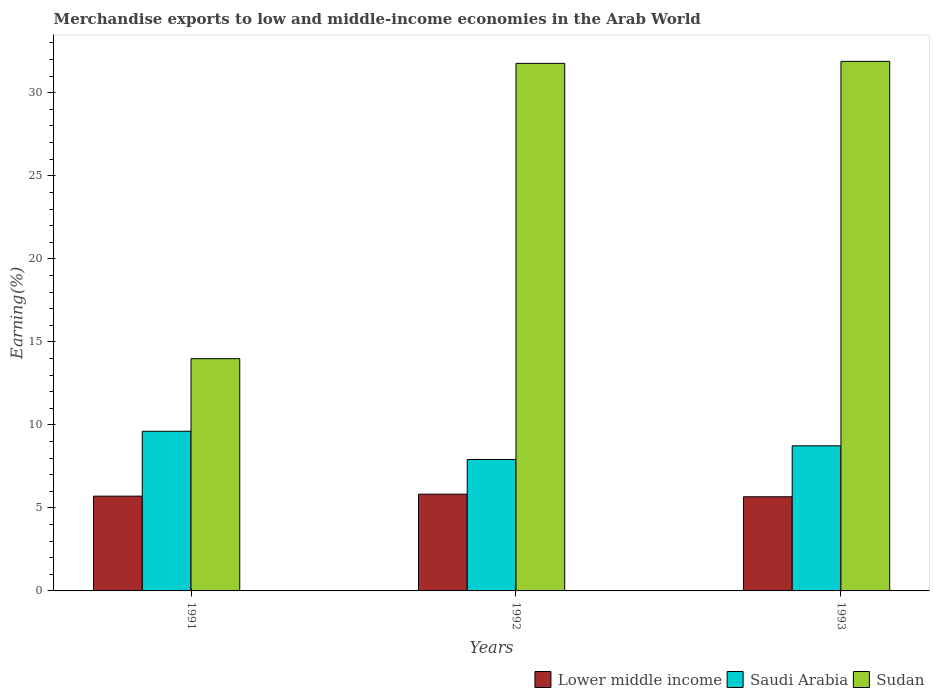How many groups of bars are there?
Give a very brief answer. 3. Are the number of bars on each tick of the X-axis equal?
Offer a terse response. Yes. How many bars are there on the 3rd tick from the left?
Your answer should be compact. 3. What is the label of the 1st group of bars from the left?
Make the answer very short. 1991. What is the percentage of amount earned from merchandise exports in Lower middle income in 1992?
Offer a terse response. 5.83. Across all years, what is the maximum percentage of amount earned from merchandise exports in Saudi Arabia?
Make the answer very short. 9.62. Across all years, what is the minimum percentage of amount earned from merchandise exports in Sudan?
Your answer should be very brief. 13.99. In which year was the percentage of amount earned from merchandise exports in Lower middle income minimum?
Make the answer very short. 1993. What is the total percentage of amount earned from merchandise exports in Saudi Arabia in the graph?
Provide a succinct answer. 26.27. What is the difference between the percentage of amount earned from merchandise exports in Lower middle income in 1991 and that in 1992?
Ensure brevity in your answer.  -0.12. What is the difference between the percentage of amount earned from merchandise exports in Saudi Arabia in 1992 and the percentage of amount earned from merchandise exports in Lower middle income in 1993?
Provide a short and direct response. 2.24. What is the average percentage of amount earned from merchandise exports in Sudan per year?
Offer a terse response. 25.88. In the year 1993, what is the difference between the percentage of amount earned from merchandise exports in Saudi Arabia and percentage of amount earned from merchandise exports in Sudan?
Ensure brevity in your answer.  -23.15. In how many years, is the percentage of amount earned from merchandise exports in Lower middle income greater than 17 %?
Give a very brief answer. 0. What is the ratio of the percentage of amount earned from merchandise exports in Saudi Arabia in 1991 to that in 1992?
Your answer should be compact. 1.22. Is the percentage of amount earned from merchandise exports in Sudan in 1991 less than that in 1992?
Provide a short and direct response. Yes. What is the difference between the highest and the second highest percentage of amount earned from merchandise exports in Sudan?
Offer a terse response. 0.12. What is the difference between the highest and the lowest percentage of amount earned from merchandise exports in Lower middle income?
Give a very brief answer. 0.16. In how many years, is the percentage of amount earned from merchandise exports in Lower middle income greater than the average percentage of amount earned from merchandise exports in Lower middle income taken over all years?
Your answer should be very brief. 1. What does the 1st bar from the left in 1992 represents?
Your response must be concise. Lower middle income. What does the 2nd bar from the right in 1992 represents?
Give a very brief answer. Saudi Arabia. How many bars are there?
Give a very brief answer. 9. Are all the bars in the graph horizontal?
Offer a terse response. No. What is the difference between two consecutive major ticks on the Y-axis?
Your response must be concise. 5. How are the legend labels stacked?
Offer a terse response. Horizontal. What is the title of the graph?
Give a very brief answer. Merchandise exports to low and middle-income economies in the Arab World. Does "Virgin Islands" appear as one of the legend labels in the graph?
Offer a very short reply. No. What is the label or title of the Y-axis?
Offer a very short reply. Earning(%). What is the Earning(%) of Lower middle income in 1991?
Your answer should be compact. 5.71. What is the Earning(%) of Saudi Arabia in 1991?
Your answer should be compact. 9.62. What is the Earning(%) of Sudan in 1991?
Your answer should be very brief. 13.99. What is the Earning(%) in Lower middle income in 1992?
Provide a succinct answer. 5.83. What is the Earning(%) of Saudi Arabia in 1992?
Give a very brief answer. 7.91. What is the Earning(%) of Sudan in 1992?
Your response must be concise. 31.77. What is the Earning(%) in Lower middle income in 1993?
Provide a short and direct response. 5.67. What is the Earning(%) in Saudi Arabia in 1993?
Your answer should be compact. 8.74. What is the Earning(%) in Sudan in 1993?
Provide a short and direct response. 31.89. Across all years, what is the maximum Earning(%) of Lower middle income?
Keep it short and to the point. 5.83. Across all years, what is the maximum Earning(%) of Saudi Arabia?
Offer a terse response. 9.62. Across all years, what is the maximum Earning(%) in Sudan?
Your answer should be very brief. 31.89. Across all years, what is the minimum Earning(%) of Lower middle income?
Offer a very short reply. 5.67. Across all years, what is the minimum Earning(%) of Saudi Arabia?
Offer a very short reply. 7.91. Across all years, what is the minimum Earning(%) of Sudan?
Provide a succinct answer. 13.99. What is the total Earning(%) in Lower middle income in the graph?
Provide a succinct answer. 17.2. What is the total Earning(%) of Saudi Arabia in the graph?
Your answer should be very brief. 26.27. What is the total Earning(%) in Sudan in the graph?
Your response must be concise. 77.65. What is the difference between the Earning(%) in Lower middle income in 1991 and that in 1992?
Your response must be concise. -0.12. What is the difference between the Earning(%) of Saudi Arabia in 1991 and that in 1992?
Ensure brevity in your answer.  1.7. What is the difference between the Earning(%) of Sudan in 1991 and that in 1992?
Your answer should be very brief. -17.78. What is the difference between the Earning(%) of Lower middle income in 1991 and that in 1993?
Provide a short and direct response. 0.04. What is the difference between the Earning(%) of Saudi Arabia in 1991 and that in 1993?
Keep it short and to the point. 0.88. What is the difference between the Earning(%) in Sudan in 1991 and that in 1993?
Give a very brief answer. -17.91. What is the difference between the Earning(%) of Lower middle income in 1992 and that in 1993?
Ensure brevity in your answer.  0.16. What is the difference between the Earning(%) in Saudi Arabia in 1992 and that in 1993?
Offer a terse response. -0.82. What is the difference between the Earning(%) of Sudan in 1992 and that in 1993?
Give a very brief answer. -0.12. What is the difference between the Earning(%) of Lower middle income in 1991 and the Earning(%) of Saudi Arabia in 1992?
Offer a very short reply. -2.21. What is the difference between the Earning(%) in Lower middle income in 1991 and the Earning(%) in Sudan in 1992?
Offer a terse response. -26.06. What is the difference between the Earning(%) of Saudi Arabia in 1991 and the Earning(%) of Sudan in 1992?
Your answer should be compact. -22.16. What is the difference between the Earning(%) in Lower middle income in 1991 and the Earning(%) in Saudi Arabia in 1993?
Offer a terse response. -3.03. What is the difference between the Earning(%) of Lower middle income in 1991 and the Earning(%) of Sudan in 1993?
Provide a short and direct response. -26.19. What is the difference between the Earning(%) in Saudi Arabia in 1991 and the Earning(%) in Sudan in 1993?
Keep it short and to the point. -22.28. What is the difference between the Earning(%) of Lower middle income in 1992 and the Earning(%) of Saudi Arabia in 1993?
Your answer should be compact. -2.91. What is the difference between the Earning(%) in Lower middle income in 1992 and the Earning(%) in Sudan in 1993?
Your answer should be very brief. -26.07. What is the difference between the Earning(%) of Saudi Arabia in 1992 and the Earning(%) of Sudan in 1993?
Provide a succinct answer. -23.98. What is the average Earning(%) in Lower middle income per year?
Make the answer very short. 5.73. What is the average Earning(%) in Saudi Arabia per year?
Offer a terse response. 8.76. What is the average Earning(%) of Sudan per year?
Your answer should be very brief. 25.88. In the year 1991, what is the difference between the Earning(%) of Lower middle income and Earning(%) of Saudi Arabia?
Provide a short and direct response. -3.91. In the year 1991, what is the difference between the Earning(%) of Lower middle income and Earning(%) of Sudan?
Your response must be concise. -8.28. In the year 1991, what is the difference between the Earning(%) in Saudi Arabia and Earning(%) in Sudan?
Offer a very short reply. -4.37. In the year 1992, what is the difference between the Earning(%) of Lower middle income and Earning(%) of Saudi Arabia?
Give a very brief answer. -2.09. In the year 1992, what is the difference between the Earning(%) of Lower middle income and Earning(%) of Sudan?
Give a very brief answer. -25.94. In the year 1992, what is the difference between the Earning(%) in Saudi Arabia and Earning(%) in Sudan?
Ensure brevity in your answer.  -23.86. In the year 1993, what is the difference between the Earning(%) of Lower middle income and Earning(%) of Saudi Arabia?
Your response must be concise. -3.07. In the year 1993, what is the difference between the Earning(%) of Lower middle income and Earning(%) of Sudan?
Your answer should be compact. -26.22. In the year 1993, what is the difference between the Earning(%) of Saudi Arabia and Earning(%) of Sudan?
Give a very brief answer. -23.15. What is the ratio of the Earning(%) of Lower middle income in 1991 to that in 1992?
Provide a short and direct response. 0.98. What is the ratio of the Earning(%) of Saudi Arabia in 1991 to that in 1992?
Make the answer very short. 1.22. What is the ratio of the Earning(%) of Sudan in 1991 to that in 1992?
Keep it short and to the point. 0.44. What is the ratio of the Earning(%) of Lower middle income in 1991 to that in 1993?
Give a very brief answer. 1.01. What is the ratio of the Earning(%) in Saudi Arabia in 1991 to that in 1993?
Your response must be concise. 1.1. What is the ratio of the Earning(%) in Sudan in 1991 to that in 1993?
Make the answer very short. 0.44. What is the ratio of the Earning(%) in Lower middle income in 1992 to that in 1993?
Your response must be concise. 1.03. What is the ratio of the Earning(%) in Saudi Arabia in 1992 to that in 1993?
Your answer should be very brief. 0.91. What is the difference between the highest and the second highest Earning(%) in Lower middle income?
Ensure brevity in your answer.  0.12. What is the difference between the highest and the second highest Earning(%) of Saudi Arabia?
Give a very brief answer. 0.88. What is the difference between the highest and the second highest Earning(%) of Sudan?
Provide a short and direct response. 0.12. What is the difference between the highest and the lowest Earning(%) in Lower middle income?
Give a very brief answer. 0.16. What is the difference between the highest and the lowest Earning(%) of Saudi Arabia?
Provide a succinct answer. 1.7. What is the difference between the highest and the lowest Earning(%) of Sudan?
Keep it short and to the point. 17.91. 